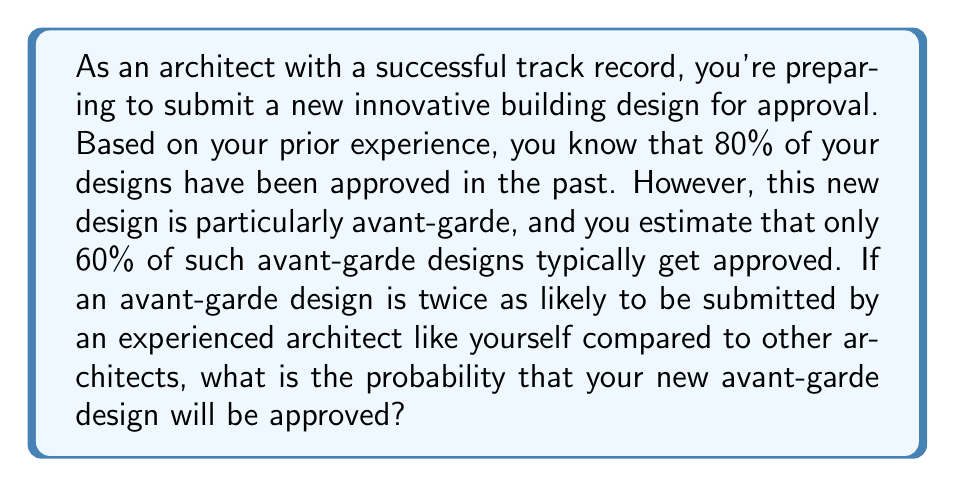Help me with this question. Let's approach this problem using Bayes' theorem. We'll define the following events:

A: The design is approved
E: The design is submitted by an experienced architect

We're given the following probabilities:

$P(A|E) = 0.80$ (probability of approval given an experienced architect)
$P(A|\text{not }E) = 0.60$ (probability of approval for avant-garde designs in general)
$P(E|AG) = 2P(\text{not }E|AG)$ (probability of an avant-garde design being submitted by an experienced architect is twice that of other architects)

We need to find $P(A|E, AG)$ (probability of approval given an experienced architect and an avant-garde design).

Using Bayes' theorem:

$$P(A|E, AG) = \frac{P(E|A, AG) \cdot P(A|AG)}{P(E|AG)}$$

We don't have $P(E|A, AG)$ directly, but we can use the law of total probability:

$$P(A|AG) = P(A|E, AG) \cdot P(E|AG) + P(A|\text{not }E, AG) \cdot P(\text{not }E|AG)$$

We know that $P(E|AG) = 2P(\text{not }E|AG)$ and $P(E|AG) + P(\text{not }E|AG) = 1$, so:

$P(E|AG) = \frac{2}{3}$ and $P(\text{not }E|AG) = \frac{1}{3}$

Substituting into the law of total probability:

$$0.60 = P(A|E, AG) \cdot \frac{2}{3} + 0.60 \cdot \frac{1}{3}$$

Solving for $P(A|E, AG)$:

$$P(A|E, AG) = \frac{0.60 - 0.60 \cdot \frac{1}{3}}{\frac{2}{3}} = 0.60$$

Therefore, the probability of your avant-garde design being approved, given your experience as an architect, is 0.60 or 60%.
Answer: The probability that the new avant-garde design will be approved is 0.60 or 60%. 